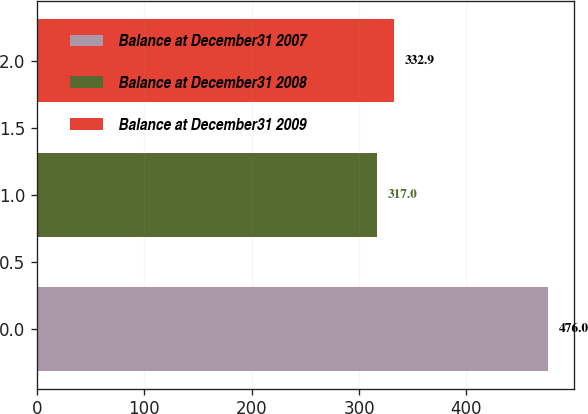Convert chart to OTSL. <chart><loc_0><loc_0><loc_500><loc_500><bar_chart><fcel>Balance at December31 2007<fcel>Balance at December31 2008<fcel>Balance at December31 2009<nl><fcel>476<fcel>317<fcel>332.9<nl></chart> 